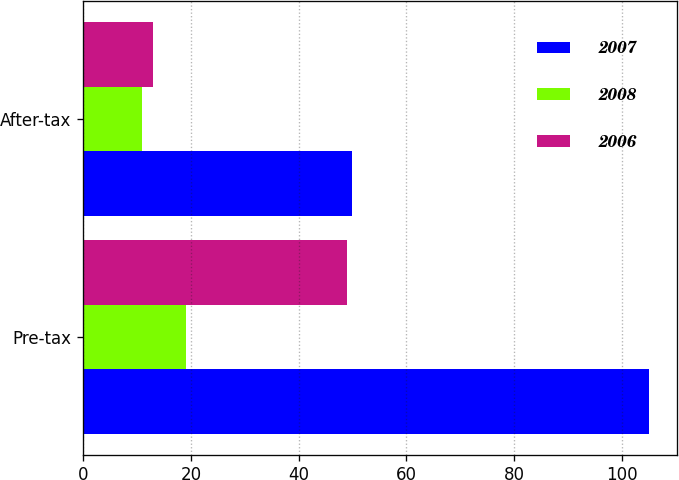Convert chart to OTSL. <chart><loc_0><loc_0><loc_500><loc_500><stacked_bar_chart><ecel><fcel>Pre-tax<fcel>After-tax<nl><fcel>2007<fcel>105<fcel>50<nl><fcel>2008<fcel>19<fcel>11<nl><fcel>2006<fcel>49<fcel>13<nl></chart> 